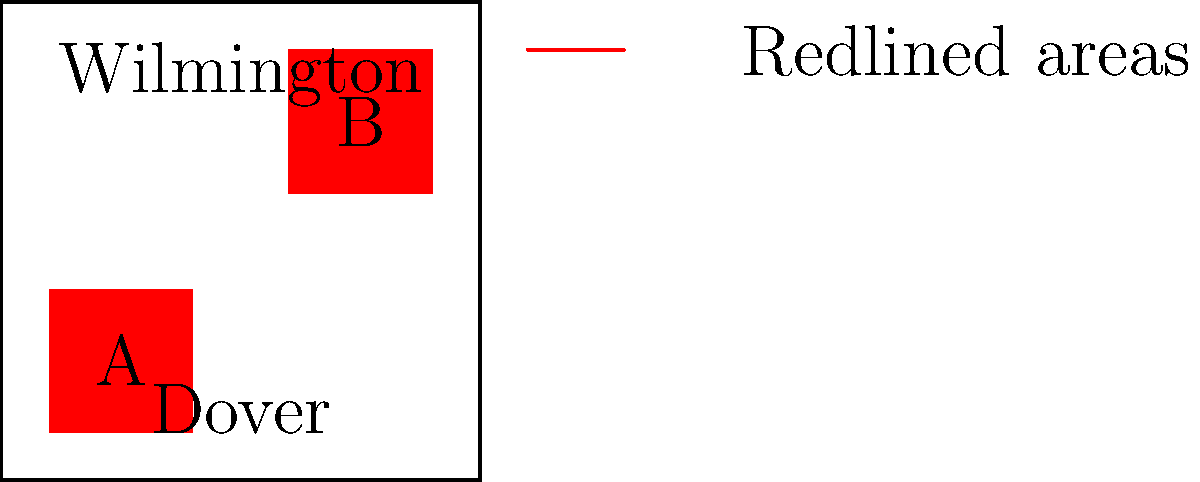Based on the map of historically redlined neighborhoods in Delaware, which of the two major cities shown appears to have been more affected by redlining practices? To answer this question, we need to analyze the map and follow these steps:

1. Identify the two major cities shown on the map:
   - Wilmington is labeled in the northern part of the state
   - Dover is labeled in the southern part of the state

2. Locate the redlined areas:
   - There are two red-shaded areas on the map, labeled A and B
   - These red areas represent historically redlined neighborhoods

3. Assess the proximity of redlined areas to each city:
   - Area A is located close to Wilmington
   - Area B is also located near Wilmington
   - There are no redlined areas shown near Dover

4. Compare the impact on each city:
   - Wilmington has two redlined areas in its vicinity
   - Dover has no visible redlined areas nearby

5. Conclude based on the visual evidence:
   - Wilmington appears to have been more affected by redlining practices
   - This is evident from the presence of two redlined areas near the city
Answer: Wilmington 